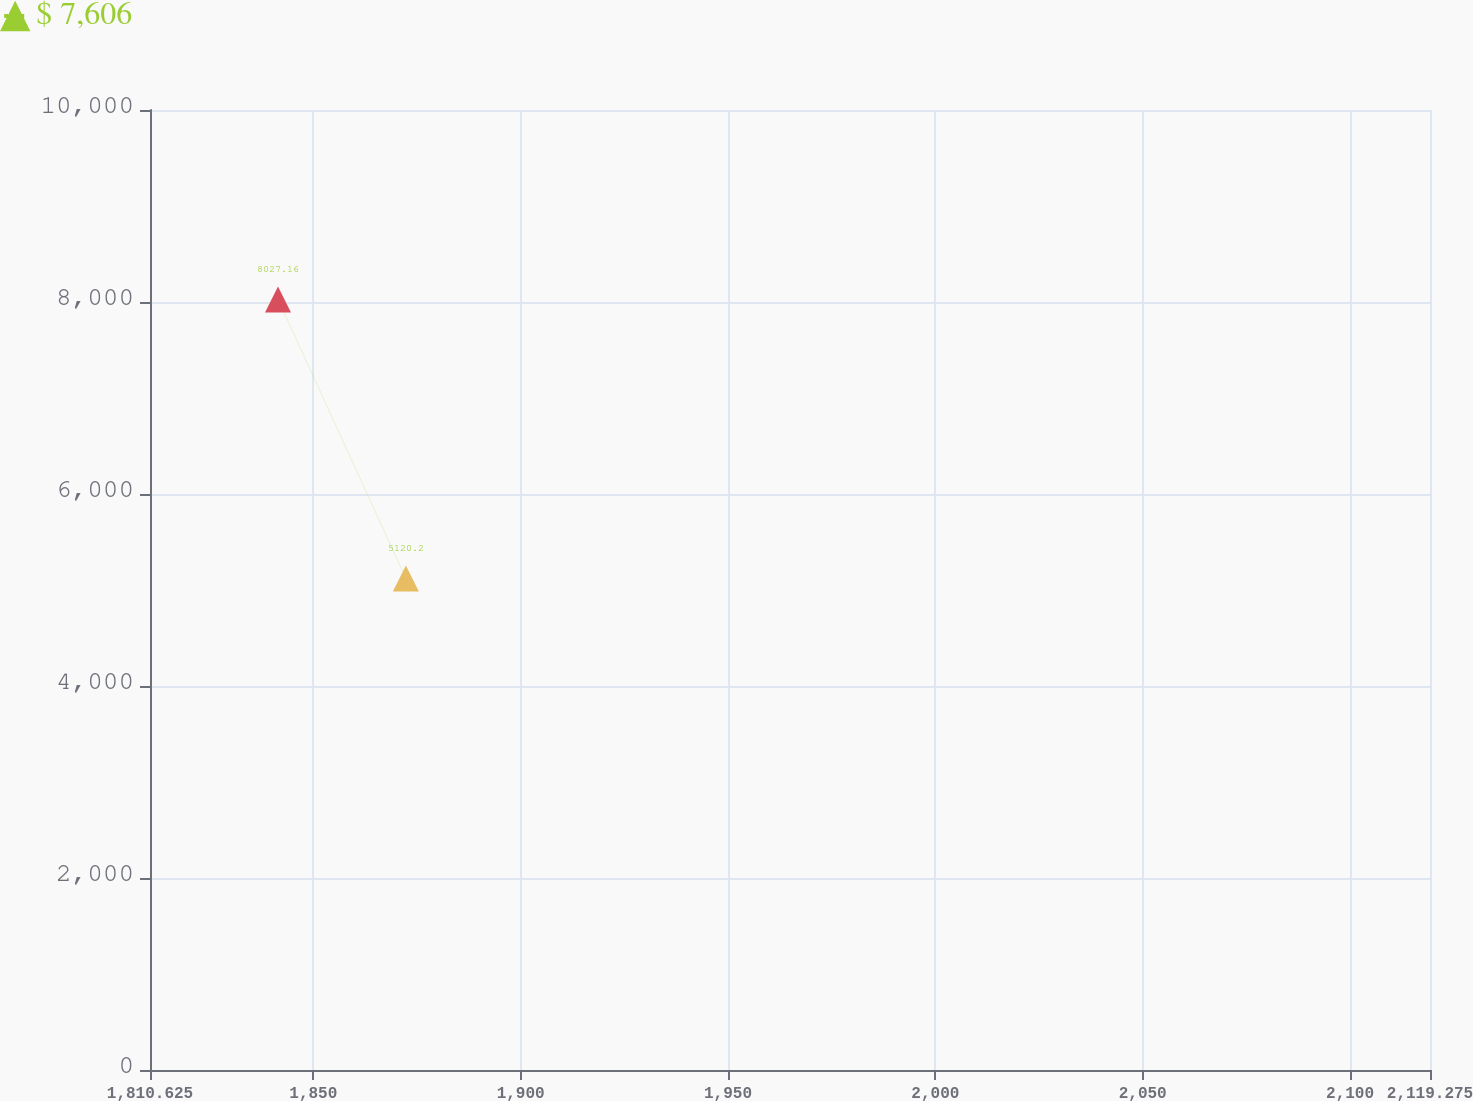Convert chart. <chart><loc_0><loc_0><loc_500><loc_500><line_chart><ecel><fcel>$ 7,606<nl><fcel>1841.49<fcel>8027.16<nl><fcel>1872.33<fcel>5120.2<nl><fcel>2119.3<fcel>3388.2<nl><fcel>2150.14<fcel>1627.89<nl></chart> 